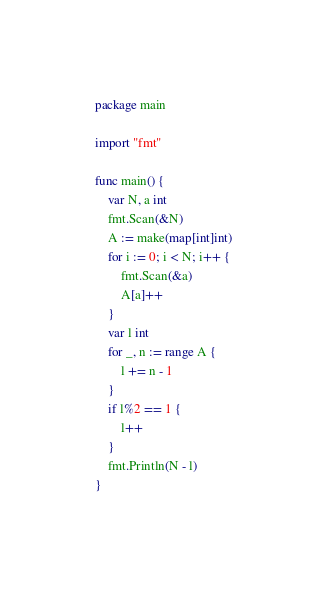<code> <loc_0><loc_0><loc_500><loc_500><_Go_>package main

import "fmt"

func main() {
	var N, a int
	fmt.Scan(&N)
	A := make(map[int]int)
	for i := 0; i < N; i++ {
		fmt.Scan(&a)
		A[a]++
	}
	var l int
	for _, n := range A {
		l += n - 1
	}
	if l%2 == 1 {
		l++
	}
	fmt.Println(N - l)
}
</code> 